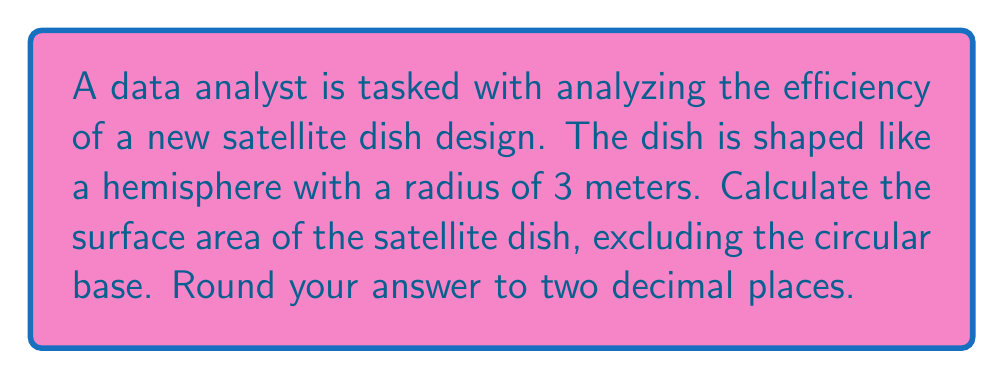Teach me how to tackle this problem. Let's approach this step-by-step:

1) The satellite dish is shaped like a hemisphere, which is half of a sphere.

2) The formula for the surface area of a sphere is:
   $$A_{sphere} = 4\pi r^2$$

3) However, we only need half of this (the hemisphere) and we're excluding the circular base. So we need to calculate:
   $$A_{dish} = \frac{1}{2} \cdot 4\pi r^2 = 2\pi r^2$$

4) We're given that the radius is 3 meters. Let's substitute this into our formula:
   $$A_{dish} = 2\pi (3)^2 = 2\pi \cdot 9 = 18\pi$$

5) Now, let's calculate this:
   $$18\pi \approx 56.5486...$$

6) Rounding to two decimal places:
   $$A_{dish} \approx 56.55 \text{ m}^2$$

This result represents the curved surface area of the hemispherical satellite dish, which is what's relevant for signal reception and transmission in data analysis applications.
Answer: $56.55 \text{ m}^2$ 